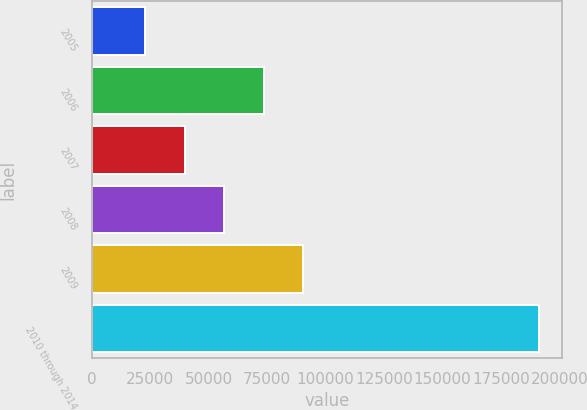<chart> <loc_0><loc_0><loc_500><loc_500><bar_chart><fcel>2005<fcel>2006<fcel>2007<fcel>2008<fcel>2009<fcel>2010 through 2014<nl><fcel>22958<fcel>73492.4<fcel>39802.8<fcel>56647.6<fcel>90337.2<fcel>191406<nl></chart> 